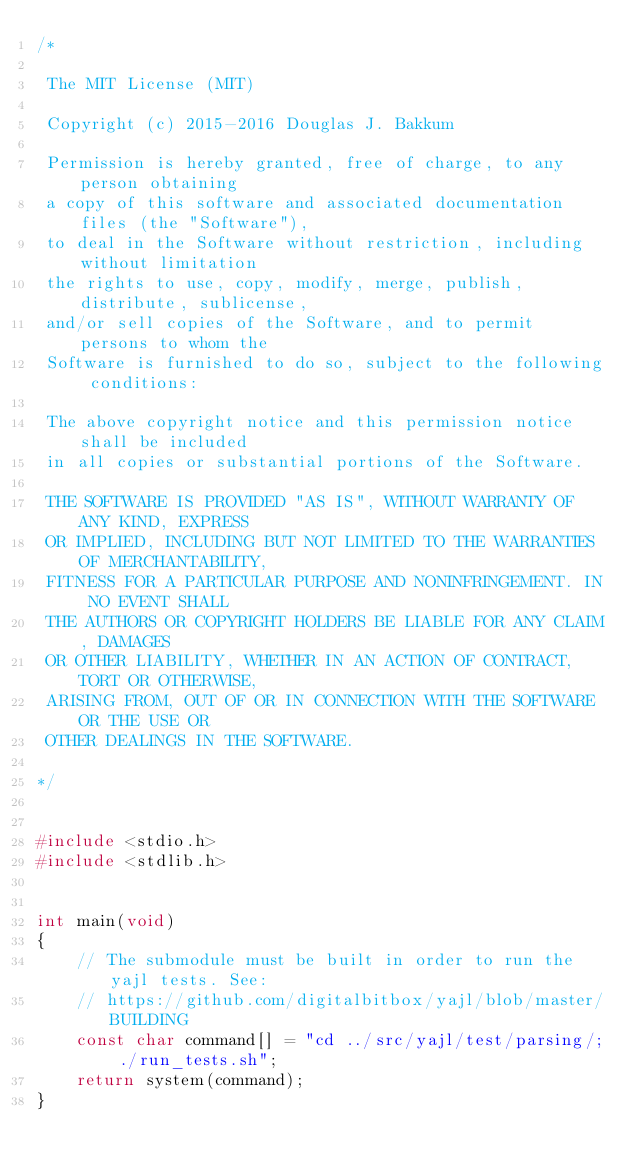<code> <loc_0><loc_0><loc_500><loc_500><_C_>/*

 The MIT License (MIT)

 Copyright (c) 2015-2016 Douglas J. Bakkum

 Permission is hereby granted, free of charge, to any person obtaining
 a copy of this software and associated documentation files (the "Software"),
 to deal in the Software without restriction, including without limitation
 the rights to use, copy, modify, merge, publish, distribute, sublicense,
 and/or sell copies of the Software, and to permit persons to whom the
 Software is furnished to do so, subject to the following conditions:

 The above copyright notice and this permission notice shall be included
 in all copies or substantial portions of the Software.

 THE SOFTWARE IS PROVIDED "AS IS", WITHOUT WARRANTY OF ANY KIND, EXPRESS
 OR IMPLIED, INCLUDING BUT NOT LIMITED TO THE WARRANTIES OF MERCHANTABILITY,
 FITNESS FOR A PARTICULAR PURPOSE AND NONINFRINGEMENT. IN NO EVENT SHALL
 THE AUTHORS OR COPYRIGHT HOLDERS BE LIABLE FOR ANY CLAIM, DAMAGES
 OR OTHER LIABILITY, WHETHER IN AN ACTION OF CONTRACT, TORT OR OTHERWISE,
 ARISING FROM, OUT OF OR IN CONNECTION WITH THE SOFTWARE OR THE USE OR
 OTHER DEALINGS IN THE SOFTWARE.

*/


#include <stdio.h>
#include <stdlib.h>


int main(void)
{
    // The submodule must be built in order to run the yajl tests. See:
    // https://github.com/digitalbitbox/yajl/blob/master/BUILDING
    const char command[] = "cd ../src/yajl/test/parsing/; ./run_tests.sh";
    return system(command);
}
</code> 